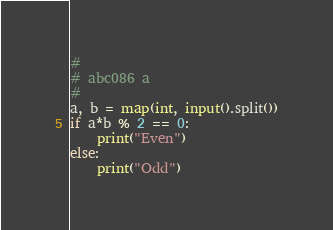Convert code to text. <code><loc_0><loc_0><loc_500><loc_500><_Python_>#
# abc086 a
#
a, b = map(int, input().split())
if a*b % 2 == 0:
    print("Even")
else:
    print("Odd")</code> 